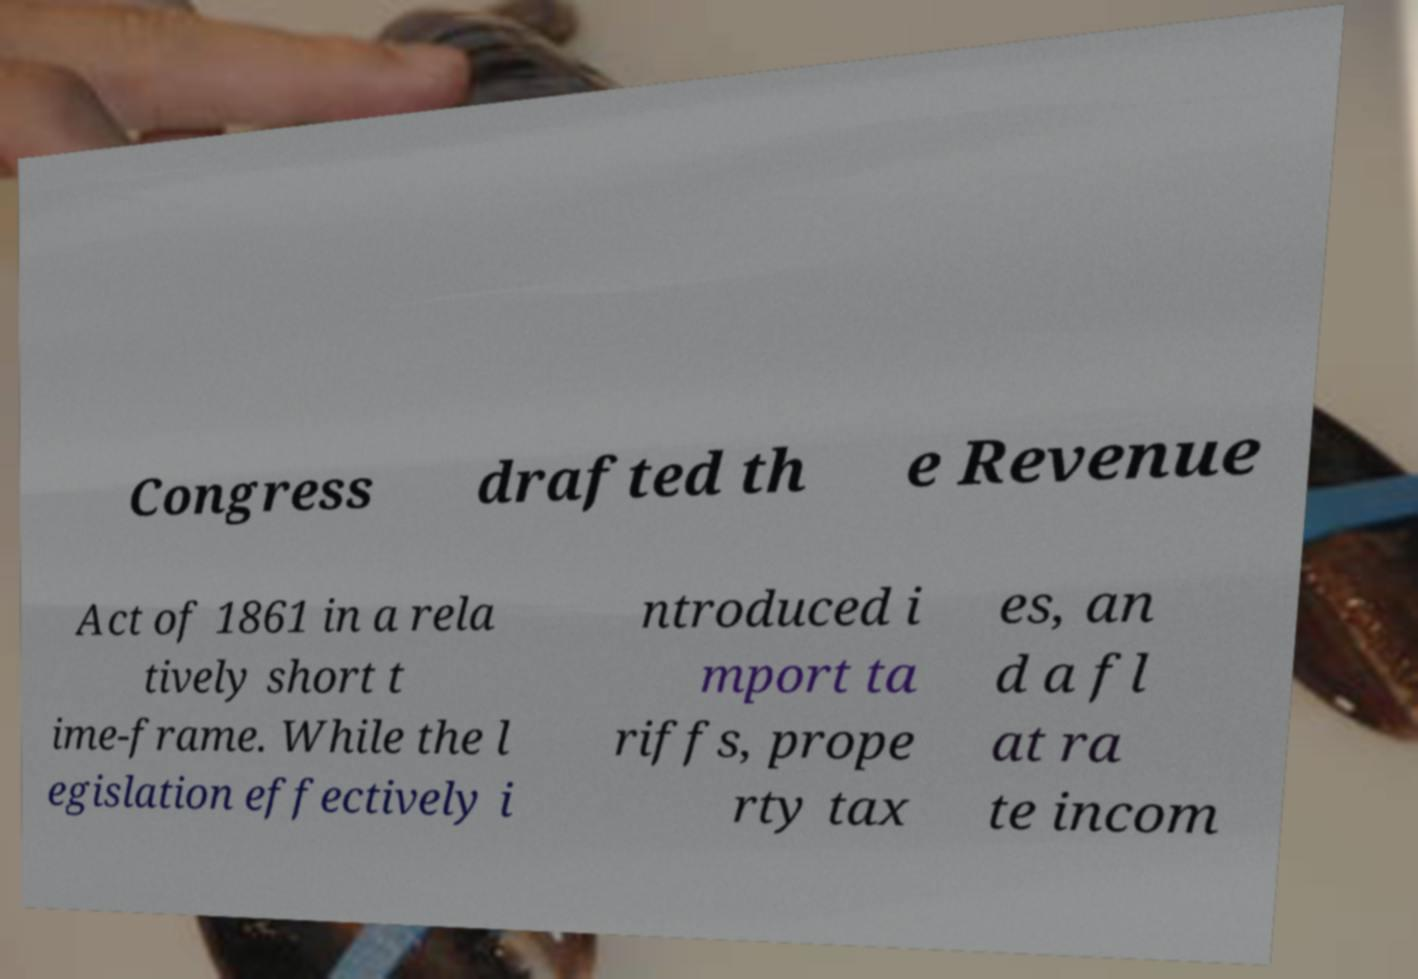Please identify and transcribe the text found in this image. Congress drafted th e Revenue Act of 1861 in a rela tively short t ime-frame. While the l egislation effectively i ntroduced i mport ta riffs, prope rty tax es, an d a fl at ra te incom 